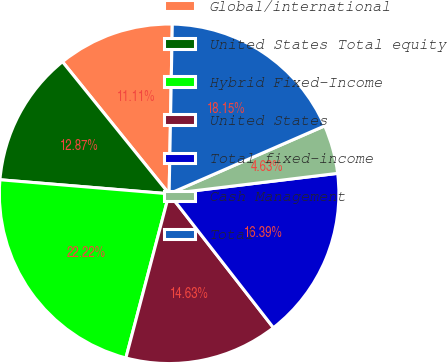Convert chart. <chart><loc_0><loc_0><loc_500><loc_500><pie_chart><fcel>Global/international<fcel>United States Total equity<fcel>Hybrid Fixed-Income<fcel>United States<fcel>Total fixed-income<fcel>Cash Management<fcel>Total<nl><fcel>11.11%<fcel>12.87%<fcel>22.22%<fcel>14.63%<fcel>16.39%<fcel>4.63%<fcel>18.15%<nl></chart> 